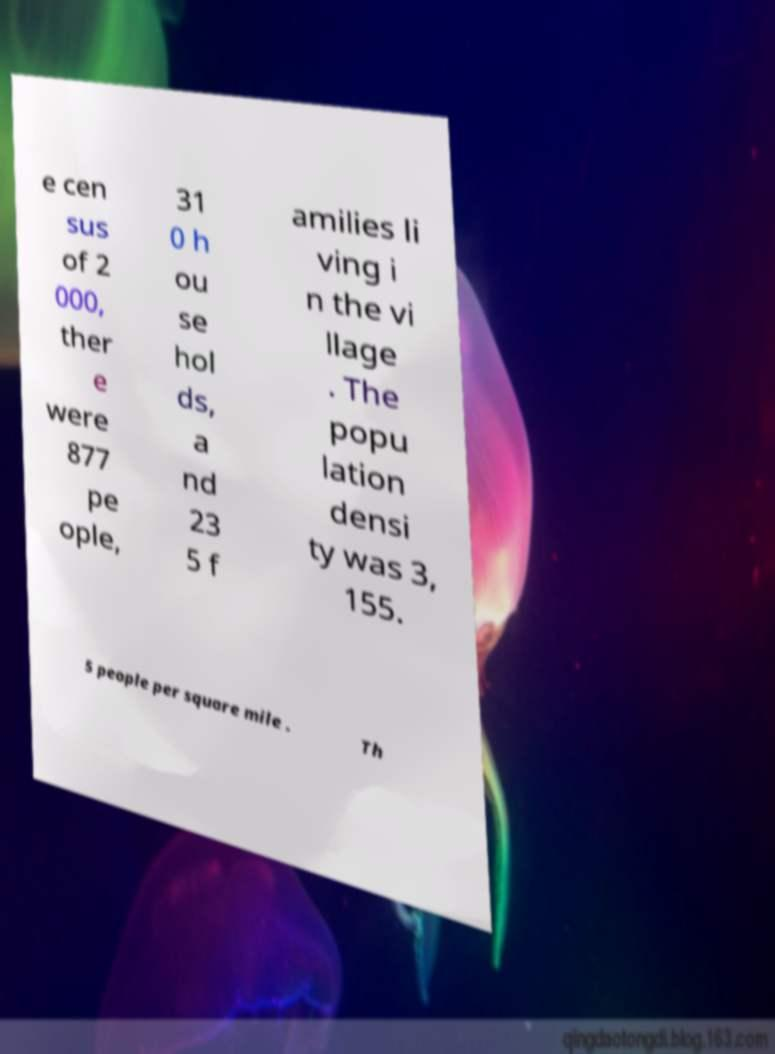Can you accurately transcribe the text from the provided image for me? e cen sus of 2 000, ther e were 877 pe ople, 31 0 h ou se hol ds, a nd 23 5 f amilies li ving i n the vi llage . The popu lation densi ty was 3, 155. 5 people per square mile . Th 